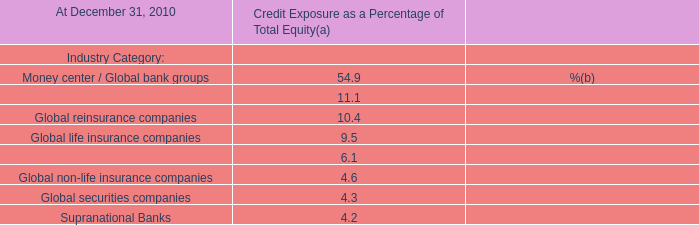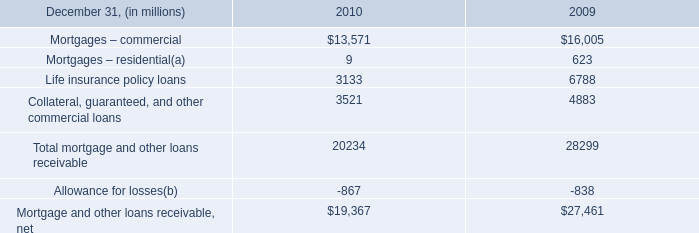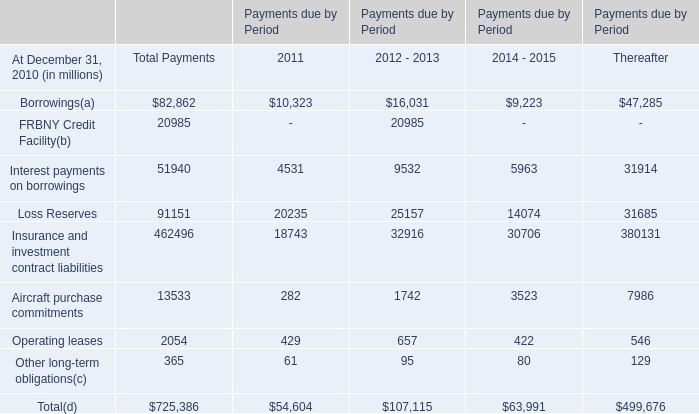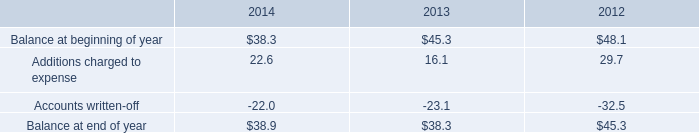as of december 31 , 2014 what was the ratio of the restricted cash and marketable securities to the balance in allowance for doubtful accounts 
Computations: (115.6 / 38.9)
Answer: 2.97172. 